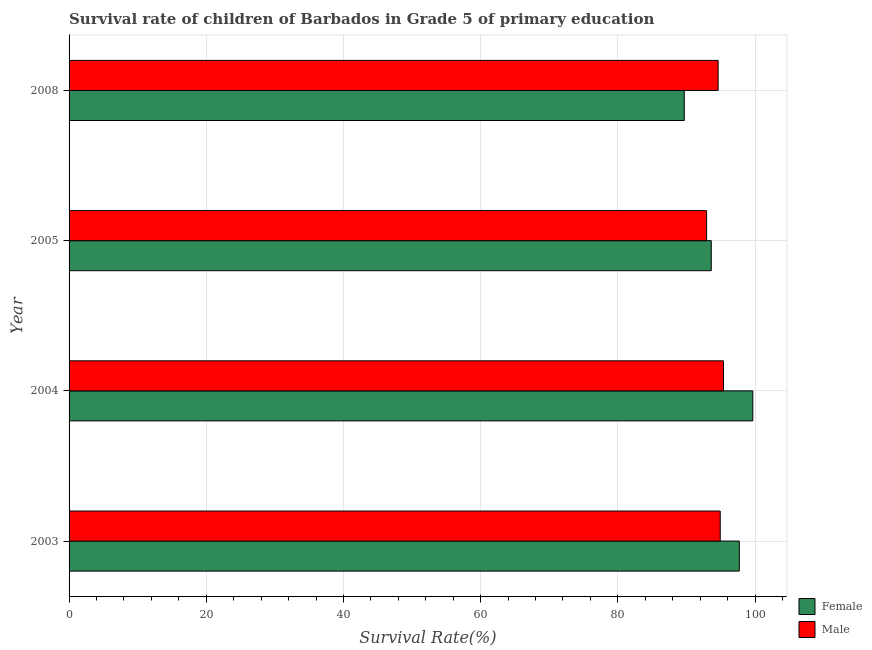Are the number of bars per tick equal to the number of legend labels?
Make the answer very short. Yes. How many bars are there on the 3rd tick from the top?
Ensure brevity in your answer.  2. What is the survival rate of male students in primary education in 2004?
Your response must be concise. 95.4. Across all years, what is the maximum survival rate of male students in primary education?
Give a very brief answer. 95.4. Across all years, what is the minimum survival rate of male students in primary education?
Give a very brief answer. 92.94. In which year was the survival rate of male students in primary education minimum?
Offer a terse response. 2005. What is the total survival rate of male students in primary education in the graph?
Provide a short and direct response. 377.89. What is the difference between the survival rate of female students in primary education in 2003 and that in 2004?
Your answer should be very brief. -1.97. What is the difference between the survival rate of female students in primary education in 2008 and the survival rate of male students in primary education in 2004?
Make the answer very short. -5.71. What is the average survival rate of male students in primary education per year?
Your answer should be compact. 94.47. In the year 2005, what is the difference between the survival rate of male students in primary education and survival rate of female students in primary education?
Your response must be concise. -0.68. In how many years, is the survival rate of male students in primary education greater than 76 %?
Your response must be concise. 4. What is the ratio of the survival rate of female students in primary education in 2003 to that in 2005?
Offer a terse response. 1.04. What is the difference between the highest and the second highest survival rate of male students in primary education?
Provide a short and direct response. 0.47. What is the difference between the highest and the lowest survival rate of female students in primary education?
Give a very brief answer. 9.99. Are the values on the major ticks of X-axis written in scientific E-notation?
Give a very brief answer. No. Does the graph contain any zero values?
Make the answer very short. No. How many legend labels are there?
Keep it short and to the point. 2. How are the legend labels stacked?
Your answer should be very brief. Vertical. What is the title of the graph?
Make the answer very short. Survival rate of children of Barbados in Grade 5 of primary education. Does "GDP at market prices" appear as one of the legend labels in the graph?
Keep it short and to the point. No. What is the label or title of the X-axis?
Make the answer very short. Survival Rate(%). What is the label or title of the Y-axis?
Provide a short and direct response. Year. What is the Survival Rate(%) of Female in 2003?
Your answer should be compact. 97.71. What is the Survival Rate(%) of Male in 2003?
Give a very brief answer. 94.93. What is the Survival Rate(%) in Female in 2004?
Ensure brevity in your answer.  99.67. What is the Survival Rate(%) in Male in 2004?
Provide a succinct answer. 95.4. What is the Survival Rate(%) of Female in 2005?
Offer a very short reply. 93.62. What is the Survival Rate(%) of Male in 2005?
Provide a succinct answer. 92.94. What is the Survival Rate(%) in Female in 2008?
Your answer should be very brief. 89.69. What is the Survival Rate(%) of Male in 2008?
Your answer should be compact. 94.62. Across all years, what is the maximum Survival Rate(%) in Female?
Offer a terse response. 99.67. Across all years, what is the maximum Survival Rate(%) of Male?
Offer a very short reply. 95.4. Across all years, what is the minimum Survival Rate(%) of Female?
Offer a terse response. 89.69. Across all years, what is the minimum Survival Rate(%) of Male?
Keep it short and to the point. 92.94. What is the total Survival Rate(%) in Female in the graph?
Your response must be concise. 380.69. What is the total Survival Rate(%) of Male in the graph?
Make the answer very short. 377.89. What is the difference between the Survival Rate(%) of Female in 2003 and that in 2004?
Your response must be concise. -1.97. What is the difference between the Survival Rate(%) of Male in 2003 and that in 2004?
Ensure brevity in your answer.  -0.47. What is the difference between the Survival Rate(%) of Female in 2003 and that in 2005?
Make the answer very short. 4.09. What is the difference between the Survival Rate(%) in Male in 2003 and that in 2005?
Offer a very short reply. 1.98. What is the difference between the Survival Rate(%) in Female in 2003 and that in 2008?
Your response must be concise. 8.02. What is the difference between the Survival Rate(%) in Male in 2003 and that in 2008?
Offer a very short reply. 0.3. What is the difference between the Survival Rate(%) in Female in 2004 and that in 2005?
Give a very brief answer. 6.05. What is the difference between the Survival Rate(%) of Male in 2004 and that in 2005?
Your response must be concise. 2.46. What is the difference between the Survival Rate(%) in Female in 2004 and that in 2008?
Make the answer very short. 9.99. What is the difference between the Survival Rate(%) of Male in 2004 and that in 2008?
Provide a short and direct response. 0.78. What is the difference between the Survival Rate(%) of Female in 2005 and that in 2008?
Offer a very short reply. 3.93. What is the difference between the Survival Rate(%) in Male in 2005 and that in 2008?
Make the answer very short. -1.68. What is the difference between the Survival Rate(%) in Female in 2003 and the Survival Rate(%) in Male in 2004?
Offer a very short reply. 2.31. What is the difference between the Survival Rate(%) of Female in 2003 and the Survival Rate(%) of Male in 2005?
Provide a short and direct response. 4.76. What is the difference between the Survival Rate(%) of Female in 2003 and the Survival Rate(%) of Male in 2008?
Provide a succinct answer. 3.08. What is the difference between the Survival Rate(%) in Female in 2004 and the Survival Rate(%) in Male in 2005?
Your answer should be very brief. 6.73. What is the difference between the Survival Rate(%) of Female in 2004 and the Survival Rate(%) of Male in 2008?
Make the answer very short. 5.05. What is the difference between the Survival Rate(%) of Female in 2005 and the Survival Rate(%) of Male in 2008?
Your answer should be very brief. -1. What is the average Survival Rate(%) of Female per year?
Your response must be concise. 95.17. What is the average Survival Rate(%) of Male per year?
Your answer should be very brief. 94.47. In the year 2003, what is the difference between the Survival Rate(%) in Female and Survival Rate(%) in Male?
Provide a succinct answer. 2.78. In the year 2004, what is the difference between the Survival Rate(%) of Female and Survival Rate(%) of Male?
Your response must be concise. 4.28. In the year 2005, what is the difference between the Survival Rate(%) of Female and Survival Rate(%) of Male?
Provide a succinct answer. 0.68. In the year 2008, what is the difference between the Survival Rate(%) in Female and Survival Rate(%) in Male?
Keep it short and to the point. -4.93. What is the ratio of the Survival Rate(%) of Female in 2003 to that in 2004?
Ensure brevity in your answer.  0.98. What is the ratio of the Survival Rate(%) in Male in 2003 to that in 2004?
Keep it short and to the point. 0.99. What is the ratio of the Survival Rate(%) of Female in 2003 to that in 2005?
Provide a short and direct response. 1.04. What is the ratio of the Survival Rate(%) in Male in 2003 to that in 2005?
Provide a short and direct response. 1.02. What is the ratio of the Survival Rate(%) in Female in 2003 to that in 2008?
Keep it short and to the point. 1.09. What is the ratio of the Survival Rate(%) of Female in 2004 to that in 2005?
Ensure brevity in your answer.  1.06. What is the ratio of the Survival Rate(%) in Male in 2004 to that in 2005?
Provide a short and direct response. 1.03. What is the ratio of the Survival Rate(%) in Female in 2004 to that in 2008?
Your answer should be very brief. 1.11. What is the ratio of the Survival Rate(%) of Male in 2004 to that in 2008?
Your response must be concise. 1.01. What is the ratio of the Survival Rate(%) in Female in 2005 to that in 2008?
Ensure brevity in your answer.  1.04. What is the ratio of the Survival Rate(%) of Male in 2005 to that in 2008?
Your response must be concise. 0.98. What is the difference between the highest and the second highest Survival Rate(%) in Female?
Offer a terse response. 1.97. What is the difference between the highest and the second highest Survival Rate(%) of Male?
Offer a very short reply. 0.47. What is the difference between the highest and the lowest Survival Rate(%) in Female?
Your response must be concise. 9.99. What is the difference between the highest and the lowest Survival Rate(%) in Male?
Give a very brief answer. 2.46. 